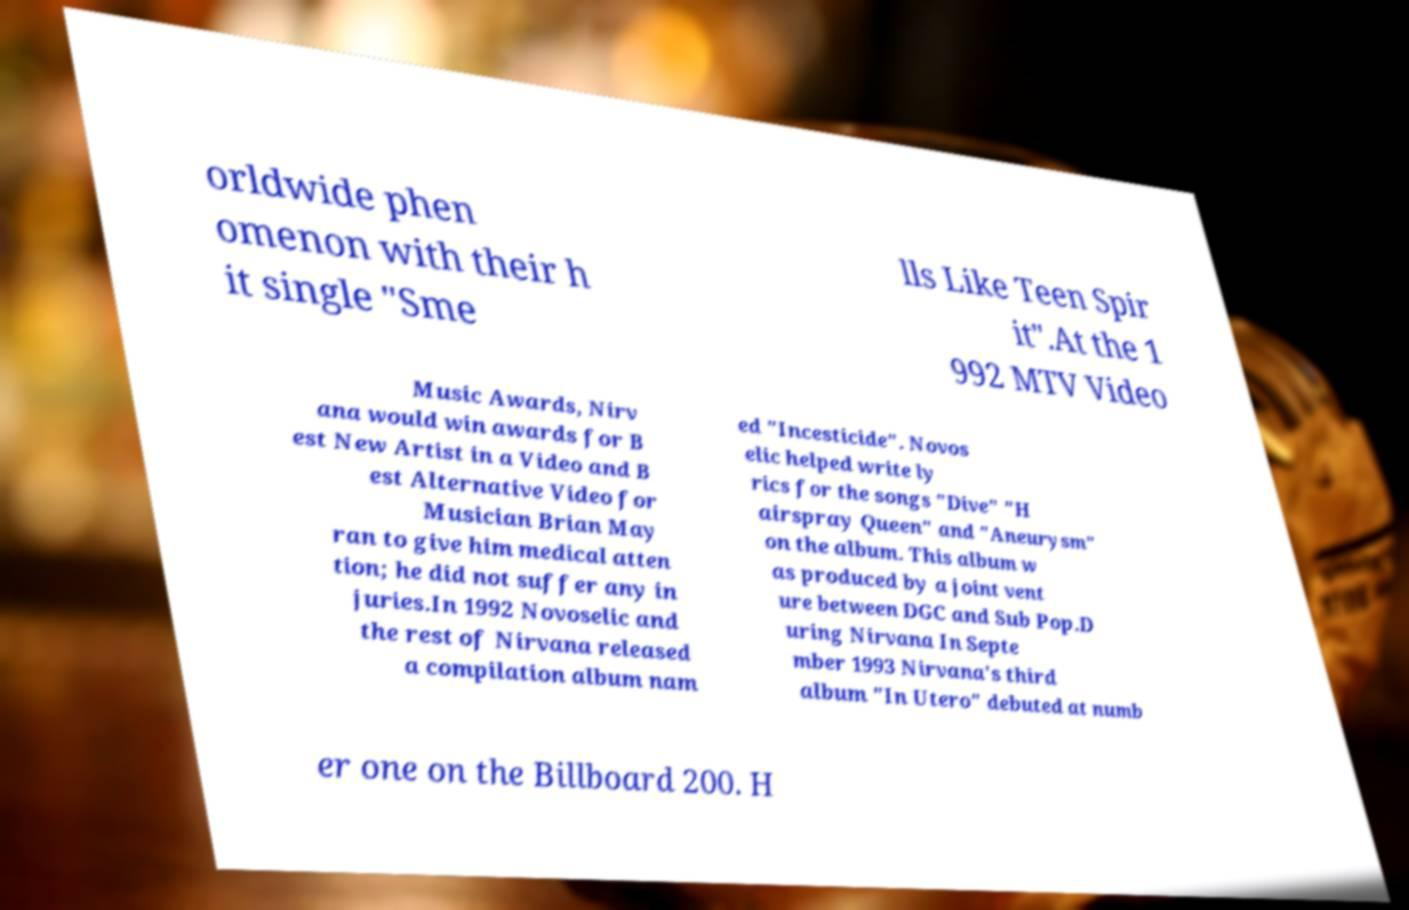Please read and relay the text visible in this image. What does it say? orldwide phen omenon with their h it single "Sme lls Like Teen Spir it".At the 1 992 MTV Video Music Awards, Nirv ana would win awards for B est New Artist in a Video and B est Alternative Video for Musician Brian May ran to give him medical atten tion; he did not suffer any in juries.In 1992 Novoselic and the rest of Nirvana released a compilation album nam ed "Incesticide". Novos elic helped write ly rics for the songs "Dive" "H airspray Queen" and "Aneurysm" on the album. This album w as produced by a joint vent ure between DGC and Sub Pop.D uring Nirvana In Septe mber 1993 Nirvana's third album "In Utero" debuted at numb er one on the Billboard 200. H 